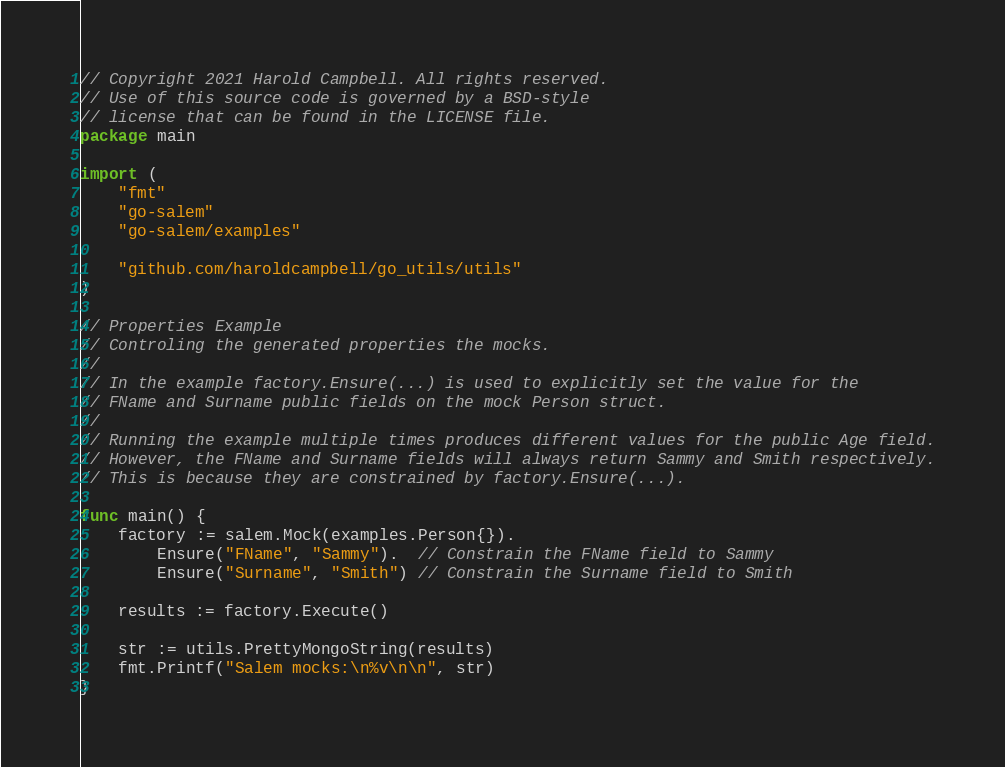Convert code to text. <code><loc_0><loc_0><loc_500><loc_500><_Go_>// Copyright 2021 Harold Campbell. All rights reserved.
// Use of this source code is governed by a BSD-style
// license that can be found in the LICENSE file.
package main

import (
	"fmt"
	"go-salem"
	"go-salem/examples"

	"github.com/haroldcampbell/go_utils/utils"
)

// Properties Example
// Controling the generated properties the mocks.
//
// In the example factory.Ensure(...) is used to explicitly set the value for the
// FName and Surname public fields on the mock Person struct.
//
// Running the example multiple times produces different values for the public Age field.
// However, the FName and Surname fields will always return Sammy and Smith respectively.
// This is because they are constrained by factory.Ensure(...).

func main() {
	factory := salem.Mock(examples.Person{}).
		Ensure("FName", "Sammy").  // Constrain the FName field to Sammy
		Ensure("Surname", "Smith") // Constrain the Surname field to Smith

	results := factory.Execute()

	str := utils.PrettyMongoString(results)
	fmt.Printf("Salem mocks:\n%v\n\n", str)
}
</code> 